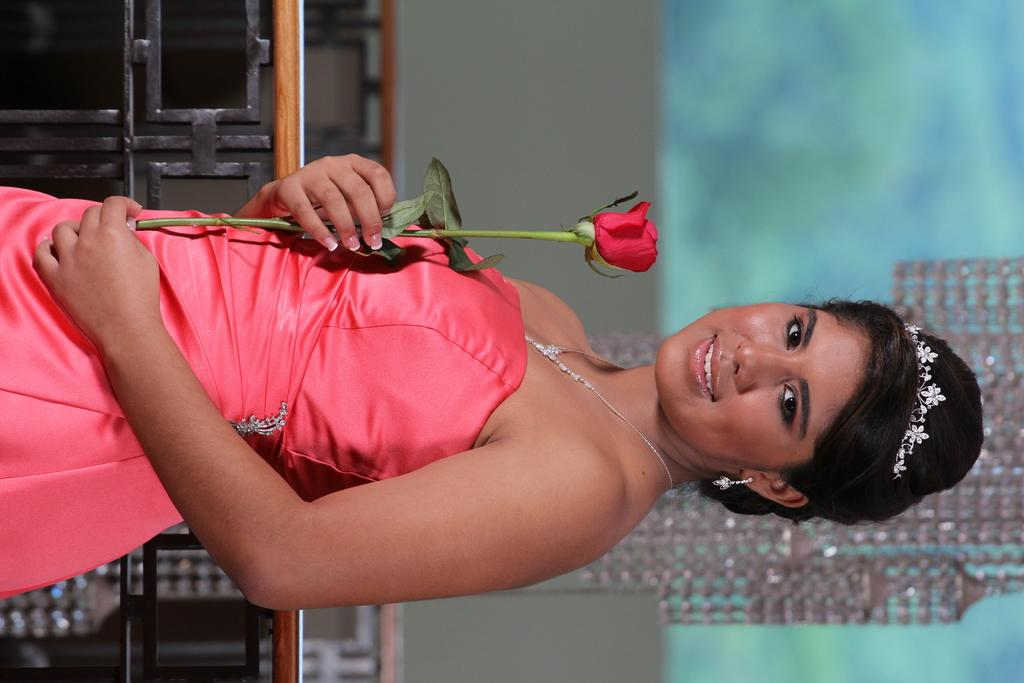What is the person in the image holding? The person is holding a rose in the image. What color is the dress the person is wearing? The person is wearing a peach-colored dress. What can be seen in the image that might be used for support or safety? There is railing visible in the image. How would you describe the background of the image? The background of the image is blurred. What type of feast is being prepared in the image? There is no indication of a feast being prepared in the image; it primarily features a person holding a rose. 